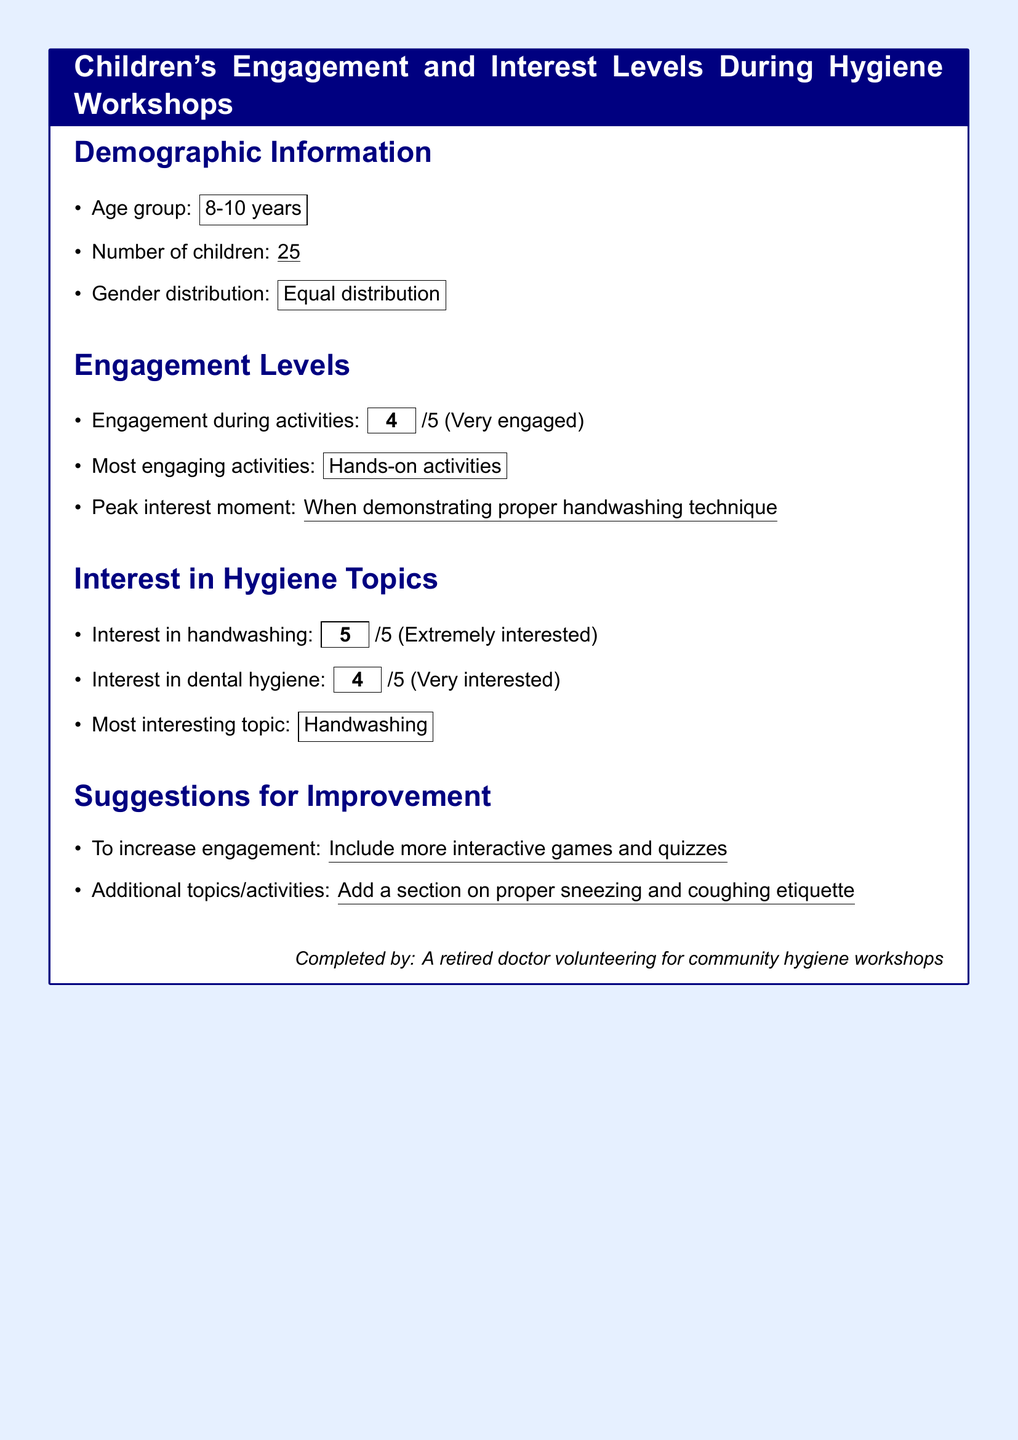What is the age group of the children? The age group is specified in the demographic information section of the document, which is from 8 to 10 years.
Answer: 8-10 years How many children participated in the workshop? The document states the number of children in the demographic section, noting that there were 25 participants.
Answer: 25 What was the engagement level during activities? This is found in the engagement levels section, where a score of 4 out of 5 indicates a high level of engagement.
Answer: 4 Which activity was deemed most engaging? The most engaging activity is listed in the engagement levels section, which is hands-on activities.
Answer: Hands-on activities What was the peak interest moment during the workshop? The peak interest moment is mentioned in the engagement levels section, specifically during the demonstration of proper handwashing technique.
Answer: When demonstrating proper handwashing technique What was the interest level in handwashing? The interest in handwashing is categorized as extremely interested, indicated by a score of 5 out of 5 in the document.
Answer: 5 What additional topic is suggested for improvement? The suggestions for improvement section includes a proposal for a discussion on proper sneezing and coughing etiquette.
Answer: Proper sneezing and coughing etiquette What score reflects the interest in dental hygiene? The score representing interest in dental hygiene is noted in the interest in hygiene topics section, which is 4 out of 5.
Answer: 4 How does the gender distribution of the participants look? The document states that the gender distribution is equal, as indicated in the demographic information section.
Answer: Equal distribution 